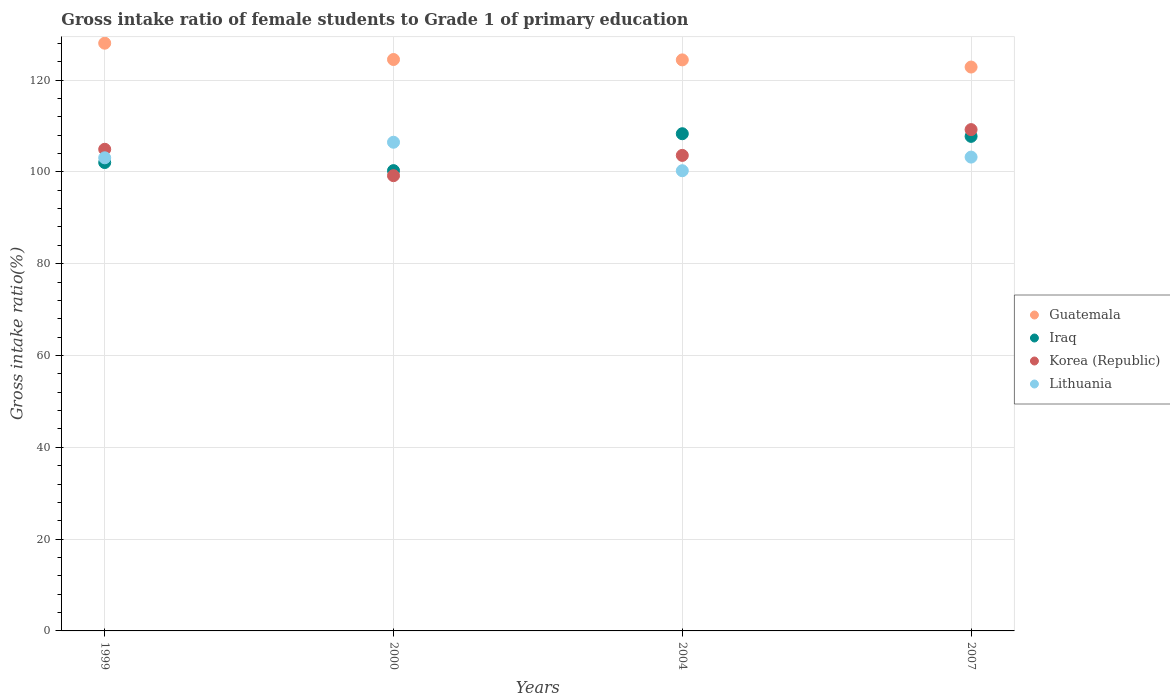How many different coloured dotlines are there?
Your response must be concise. 4. Is the number of dotlines equal to the number of legend labels?
Provide a short and direct response. Yes. What is the gross intake ratio in Iraq in 2000?
Your answer should be compact. 100.26. Across all years, what is the maximum gross intake ratio in Korea (Republic)?
Make the answer very short. 109.2. Across all years, what is the minimum gross intake ratio in Iraq?
Offer a very short reply. 100.26. In which year was the gross intake ratio in Iraq minimum?
Provide a short and direct response. 2000. What is the total gross intake ratio in Iraq in the graph?
Provide a succinct answer. 418.31. What is the difference between the gross intake ratio in Lithuania in 2004 and that in 2007?
Keep it short and to the point. -2.97. What is the difference between the gross intake ratio in Lithuania in 2004 and the gross intake ratio in Guatemala in 1999?
Provide a succinct answer. -27.78. What is the average gross intake ratio in Guatemala per year?
Provide a succinct answer. 124.93. In the year 1999, what is the difference between the gross intake ratio in Iraq and gross intake ratio in Lithuania?
Ensure brevity in your answer.  -1.03. What is the ratio of the gross intake ratio in Iraq in 2000 to that in 2007?
Your answer should be compact. 0.93. Is the gross intake ratio in Lithuania in 2000 less than that in 2004?
Provide a short and direct response. No. What is the difference between the highest and the second highest gross intake ratio in Korea (Republic)?
Offer a terse response. 4.28. What is the difference between the highest and the lowest gross intake ratio in Korea (Republic)?
Give a very brief answer. 10.03. Does the gross intake ratio in Iraq monotonically increase over the years?
Ensure brevity in your answer.  No. Is the gross intake ratio in Guatemala strictly greater than the gross intake ratio in Iraq over the years?
Your answer should be compact. Yes. How many years are there in the graph?
Give a very brief answer. 4. What is the difference between two consecutive major ticks on the Y-axis?
Provide a succinct answer. 20. Does the graph contain grids?
Give a very brief answer. Yes. What is the title of the graph?
Ensure brevity in your answer.  Gross intake ratio of female students to Grade 1 of primary education. Does "Sierra Leone" appear as one of the legend labels in the graph?
Your response must be concise. No. What is the label or title of the X-axis?
Offer a very short reply. Years. What is the label or title of the Y-axis?
Provide a short and direct response. Gross intake ratio(%). What is the Gross intake ratio(%) in Guatemala in 1999?
Ensure brevity in your answer.  128.02. What is the Gross intake ratio(%) in Iraq in 1999?
Your answer should be very brief. 102.02. What is the Gross intake ratio(%) of Korea (Republic) in 1999?
Ensure brevity in your answer.  104.91. What is the Gross intake ratio(%) in Lithuania in 1999?
Your answer should be very brief. 103.06. What is the Gross intake ratio(%) of Guatemala in 2000?
Provide a succinct answer. 124.47. What is the Gross intake ratio(%) in Iraq in 2000?
Your answer should be compact. 100.26. What is the Gross intake ratio(%) in Korea (Republic) in 2000?
Keep it short and to the point. 99.16. What is the Gross intake ratio(%) in Lithuania in 2000?
Offer a terse response. 106.45. What is the Gross intake ratio(%) of Guatemala in 2004?
Give a very brief answer. 124.38. What is the Gross intake ratio(%) of Iraq in 2004?
Make the answer very short. 108.3. What is the Gross intake ratio(%) of Korea (Republic) in 2004?
Your answer should be compact. 103.58. What is the Gross intake ratio(%) of Lithuania in 2004?
Your response must be concise. 100.24. What is the Gross intake ratio(%) of Guatemala in 2007?
Your answer should be very brief. 122.83. What is the Gross intake ratio(%) of Iraq in 2007?
Offer a terse response. 107.72. What is the Gross intake ratio(%) in Korea (Republic) in 2007?
Give a very brief answer. 109.2. What is the Gross intake ratio(%) in Lithuania in 2007?
Your answer should be compact. 103.21. Across all years, what is the maximum Gross intake ratio(%) of Guatemala?
Keep it short and to the point. 128.02. Across all years, what is the maximum Gross intake ratio(%) in Iraq?
Offer a terse response. 108.3. Across all years, what is the maximum Gross intake ratio(%) in Korea (Republic)?
Your answer should be compact. 109.2. Across all years, what is the maximum Gross intake ratio(%) in Lithuania?
Your response must be concise. 106.45. Across all years, what is the minimum Gross intake ratio(%) of Guatemala?
Provide a succinct answer. 122.83. Across all years, what is the minimum Gross intake ratio(%) of Iraq?
Provide a succinct answer. 100.26. Across all years, what is the minimum Gross intake ratio(%) in Korea (Republic)?
Offer a terse response. 99.16. Across all years, what is the minimum Gross intake ratio(%) in Lithuania?
Ensure brevity in your answer.  100.24. What is the total Gross intake ratio(%) of Guatemala in the graph?
Give a very brief answer. 499.7. What is the total Gross intake ratio(%) in Iraq in the graph?
Your answer should be compact. 418.31. What is the total Gross intake ratio(%) in Korea (Republic) in the graph?
Offer a very short reply. 416.86. What is the total Gross intake ratio(%) of Lithuania in the graph?
Offer a very short reply. 412.96. What is the difference between the Gross intake ratio(%) in Guatemala in 1999 and that in 2000?
Your answer should be compact. 3.55. What is the difference between the Gross intake ratio(%) of Iraq in 1999 and that in 2000?
Your answer should be compact. 1.76. What is the difference between the Gross intake ratio(%) in Korea (Republic) in 1999 and that in 2000?
Offer a very short reply. 5.75. What is the difference between the Gross intake ratio(%) in Lithuania in 1999 and that in 2000?
Your answer should be compact. -3.39. What is the difference between the Gross intake ratio(%) in Guatemala in 1999 and that in 2004?
Your answer should be very brief. 3.64. What is the difference between the Gross intake ratio(%) in Iraq in 1999 and that in 2004?
Offer a terse response. -6.28. What is the difference between the Gross intake ratio(%) of Korea (Republic) in 1999 and that in 2004?
Offer a terse response. 1.33. What is the difference between the Gross intake ratio(%) in Lithuania in 1999 and that in 2004?
Your answer should be very brief. 2.81. What is the difference between the Gross intake ratio(%) in Guatemala in 1999 and that in 2007?
Give a very brief answer. 5.19. What is the difference between the Gross intake ratio(%) in Iraq in 1999 and that in 2007?
Give a very brief answer. -5.7. What is the difference between the Gross intake ratio(%) of Korea (Republic) in 1999 and that in 2007?
Make the answer very short. -4.28. What is the difference between the Gross intake ratio(%) of Lithuania in 1999 and that in 2007?
Your response must be concise. -0.16. What is the difference between the Gross intake ratio(%) of Guatemala in 2000 and that in 2004?
Offer a very short reply. 0.08. What is the difference between the Gross intake ratio(%) in Iraq in 2000 and that in 2004?
Keep it short and to the point. -8.04. What is the difference between the Gross intake ratio(%) in Korea (Republic) in 2000 and that in 2004?
Your answer should be compact. -4.42. What is the difference between the Gross intake ratio(%) in Lithuania in 2000 and that in 2004?
Keep it short and to the point. 6.21. What is the difference between the Gross intake ratio(%) in Guatemala in 2000 and that in 2007?
Your response must be concise. 1.64. What is the difference between the Gross intake ratio(%) of Iraq in 2000 and that in 2007?
Offer a very short reply. -7.46. What is the difference between the Gross intake ratio(%) of Korea (Republic) in 2000 and that in 2007?
Ensure brevity in your answer.  -10.03. What is the difference between the Gross intake ratio(%) of Lithuania in 2000 and that in 2007?
Your answer should be very brief. 3.24. What is the difference between the Gross intake ratio(%) of Guatemala in 2004 and that in 2007?
Ensure brevity in your answer.  1.56. What is the difference between the Gross intake ratio(%) in Iraq in 2004 and that in 2007?
Your answer should be very brief. 0.58. What is the difference between the Gross intake ratio(%) in Korea (Republic) in 2004 and that in 2007?
Ensure brevity in your answer.  -5.62. What is the difference between the Gross intake ratio(%) of Lithuania in 2004 and that in 2007?
Offer a terse response. -2.97. What is the difference between the Gross intake ratio(%) in Guatemala in 1999 and the Gross intake ratio(%) in Iraq in 2000?
Offer a very short reply. 27.76. What is the difference between the Gross intake ratio(%) of Guatemala in 1999 and the Gross intake ratio(%) of Korea (Republic) in 2000?
Your answer should be compact. 28.86. What is the difference between the Gross intake ratio(%) of Guatemala in 1999 and the Gross intake ratio(%) of Lithuania in 2000?
Keep it short and to the point. 21.57. What is the difference between the Gross intake ratio(%) of Iraq in 1999 and the Gross intake ratio(%) of Korea (Republic) in 2000?
Provide a short and direct response. 2.86. What is the difference between the Gross intake ratio(%) of Iraq in 1999 and the Gross intake ratio(%) of Lithuania in 2000?
Your answer should be very brief. -4.42. What is the difference between the Gross intake ratio(%) of Korea (Republic) in 1999 and the Gross intake ratio(%) of Lithuania in 2000?
Make the answer very short. -1.53. What is the difference between the Gross intake ratio(%) of Guatemala in 1999 and the Gross intake ratio(%) of Iraq in 2004?
Keep it short and to the point. 19.72. What is the difference between the Gross intake ratio(%) in Guatemala in 1999 and the Gross intake ratio(%) in Korea (Republic) in 2004?
Give a very brief answer. 24.44. What is the difference between the Gross intake ratio(%) of Guatemala in 1999 and the Gross intake ratio(%) of Lithuania in 2004?
Keep it short and to the point. 27.78. What is the difference between the Gross intake ratio(%) in Iraq in 1999 and the Gross intake ratio(%) in Korea (Republic) in 2004?
Offer a terse response. -1.56. What is the difference between the Gross intake ratio(%) in Iraq in 1999 and the Gross intake ratio(%) in Lithuania in 2004?
Keep it short and to the point. 1.78. What is the difference between the Gross intake ratio(%) in Korea (Republic) in 1999 and the Gross intake ratio(%) in Lithuania in 2004?
Your answer should be compact. 4.67. What is the difference between the Gross intake ratio(%) in Guatemala in 1999 and the Gross intake ratio(%) in Iraq in 2007?
Ensure brevity in your answer.  20.3. What is the difference between the Gross intake ratio(%) in Guatemala in 1999 and the Gross intake ratio(%) in Korea (Republic) in 2007?
Keep it short and to the point. 18.82. What is the difference between the Gross intake ratio(%) of Guatemala in 1999 and the Gross intake ratio(%) of Lithuania in 2007?
Your answer should be very brief. 24.81. What is the difference between the Gross intake ratio(%) in Iraq in 1999 and the Gross intake ratio(%) in Korea (Republic) in 2007?
Offer a very short reply. -7.17. What is the difference between the Gross intake ratio(%) in Iraq in 1999 and the Gross intake ratio(%) in Lithuania in 2007?
Provide a short and direct response. -1.19. What is the difference between the Gross intake ratio(%) of Korea (Republic) in 1999 and the Gross intake ratio(%) of Lithuania in 2007?
Your answer should be compact. 1.7. What is the difference between the Gross intake ratio(%) in Guatemala in 2000 and the Gross intake ratio(%) in Iraq in 2004?
Provide a succinct answer. 16.17. What is the difference between the Gross intake ratio(%) of Guatemala in 2000 and the Gross intake ratio(%) of Korea (Republic) in 2004?
Your answer should be compact. 20.89. What is the difference between the Gross intake ratio(%) in Guatemala in 2000 and the Gross intake ratio(%) in Lithuania in 2004?
Give a very brief answer. 24.23. What is the difference between the Gross intake ratio(%) in Iraq in 2000 and the Gross intake ratio(%) in Korea (Republic) in 2004?
Keep it short and to the point. -3.32. What is the difference between the Gross intake ratio(%) of Iraq in 2000 and the Gross intake ratio(%) of Lithuania in 2004?
Provide a succinct answer. 0.02. What is the difference between the Gross intake ratio(%) of Korea (Republic) in 2000 and the Gross intake ratio(%) of Lithuania in 2004?
Provide a short and direct response. -1.08. What is the difference between the Gross intake ratio(%) of Guatemala in 2000 and the Gross intake ratio(%) of Iraq in 2007?
Ensure brevity in your answer.  16.74. What is the difference between the Gross intake ratio(%) in Guatemala in 2000 and the Gross intake ratio(%) in Korea (Republic) in 2007?
Offer a very short reply. 15.27. What is the difference between the Gross intake ratio(%) of Guatemala in 2000 and the Gross intake ratio(%) of Lithuania in 2007?
Your answer should be very brief. 21.26. What is the difference between the Gross intake ratio(%) of Iraq in 2000 and the Gross intake ratio(%) of Korea (Republic) in 2007?
Keep it short and to the point. -8.94. What is the difference between the Gross intake ratio(%) in Iraq in 2000 and the Gross intake ratio(%) in Lithuania in 2007?
Give a very brief answer. -2.95. What is the difference between the Gross intake ratio(%) in Korea (Republic) in 2000 and the Gross intake ratio(%) in Lithuania in 2007?
Offer a terse response. -4.05. What is the difference between the Gross intake ratio(%) of Guatemala in 2004 and the Gross intake ratio(%) of Iraq in 2007?
Offer a very short reply. 16.66. What is the difference between the Gross intake ratio(%) of Guatemala in 2004 and the Gross intake ratio(%) of Korea (Republic) in 2007?
Your answer should be very brief. 15.19. What is the difference between the Gross intake ratio(%) of Guatemala in 2004 and the Gross intake ratio(%) of Lithuania in 2007?
Your answer should be compact. 21.17. What is the difference between the Gross intake ratio(%) of Iraq in 2004 and the Gross intake ratio(%) of Korea (Republic) in 2007?
Your answer should be compact. -0.9. What is the difference between the Gross intake ratio(%) in Iraq in 2004 and the Gross intake ratio(%) in Lithuania in 2007?
Your answer should be very brief. 5.09. What is the difference between the Gross intake ratio(%) in Korea (Republic) in 2004 and the Gross intake ratio(%) in Lithuania in 2007?
Your response must be concise. 0.37. What is the average Gross intake ratio(%) of Guatemala per year?
Provide a short and direct response. 124.92. What is the average Gross intake ratio(%) of Iraq per year?
Your answer should be compact. 104.58. What is the average Gross intake ratio(%) of Korea (Republic) per year?
Ensure brevity in your answer.  104.21. What is the average Gross intake ratio(%) of Lithuania per year?
Offer a very short reply. 103.24. In the year 1999, what is the difference between the Gross intake ratio(%) of Guatemala and Gross intake ratio(%) of Iraq?
Offer a terse response. 26. In the year 1999, what is the difference between the Gross intake ratio(%) in Guatemala and Gross intake ratio(%) in Korea (Republic)?
Your answer should be compact. 23.11. In the year 1999, what is the difference between the Gross intake ratio(%) in Guatemala and Gross intake ratio(%) in Lithuania?
Make the answer very short. 24.96. In the year 1999, what is the difference between the Gross intake ratio(%) of Iraq and Gross intake ratio(%) of Korea (Republic)?
Your answer should be compact. -2.89. In the year 1999, what is the difference between the Gross intake ratio(%) in Iraq and Gross intake ratio(%) in Lithuania?
Offer a very short reply. -1.03. In the year 1999, what is the difference between the Gross intake ratio(%) of Korea (Republic) and Gross intake ratio(%) of Lithuania?
Ensure brevity in your answer.  1.86. In the year 2000, what is the difference between the Gross intake ratio(%) of Guatemala and Gross intake ratio(%) of Iraq?
Ensure brevity in your answer.  24.21. In the year 2000, what is the difference between the Gross intake ratio(%) in Guatemala and Gross intake ratio(%) in Korea (Republic)?
Give a very brief answer. 25.3. In the year 2000, what is the difference between the Gross intake ratio(%) in Guatemala and Gross intake ratio(%) in Lithuania?
Offer a very short reply. 18.02. In the year 2000, what is the difference between the Gross intake ratio(%) in Iraq and Gross intake ratio(%) in Korea (Republic)?
Provide a short and direct response. 1.1. In the year 2000, what is the difference between the Gross intake ratio(%) of Iraq and Gross intake ratio(%) of Lithuania?
Provide a short and direct response. -6.19. In the year 2000, what is the difference between the Gross intake ratio(%) in Korea (Republic) and Gross intake ratio(%) in Lithuania?
Make the answer very short. -7.28. In the year 2004, what is the difference between the Gross intake ratio(%) in Guatemala and Gross intake ratio(%) in Iraq?
Offer a very short reply. 16.08. In the year 2004, what is the difference between the Gross intake ratio(%) in Guatemala and Gross intake ratio(%) in Korea (Republic)?
Give a very brief answer. 20.8. In the year 2004, what is the difference between the Gross intake ratio(%) in Guatemala and Gross intake ratio(%) in Lithuania?
Ensure brevity in your answer.  24.14. In the year 2004, what is the difference between the Gross intake ratio(%) in Iraq and Gross intake ratio(%) in Korea (Republic)?
Provide a succinct answer. 4.72. In the year 2004, what is the difference between the Gross intake ratio(%) of Iraq and Gross intake ratio(%) of Lithuania?
Give a very brief answer. 8.06. In the year 2004, what is the difference between the Gross intake ratio(%) of Korea (Republic) and Gross intake ratio(%) of Lithuania?
Your answer should be compact. 3.34. In the year 2007, what is the difference between the Gross intake ratio(%) of Guatemala and Gross intake ratio(%) of Iraq?
Ensure brevity in your answer.  15.1. In the year 2007, what is the difference between the Gross intake ratio(%) of Guatemala and Gross intake ratio(%) of Korea (Republic)?
Provide a succinct answer. 13.63. In the year 2007, what is the difference between the Gross intake ratio(%) of Guatemala and Gross intake ratio(%) of Lithuania?
Your answer should be compact. 19.61. In the year 2007, what is the difference between the Gross intake ratio(%) in Iraq and Gross intake ratio(%) in Korea (Republic)?
Offer a terse response. -1.47. In the year 2007, what is the difference between the Gross intake ratio(%) of Iraq and Gross intake ratio(%) of Lithuania?
Keep it short and to the point. 4.51. In the year 2007, what is the difference between the Gross intake ratio(%) in Korea (Republic) and Gross intake ratio(%) in Lithuania?
Offer a terse response. 5.99. What is the ratio of the Gross intake ratio(%) in Guatemala in 1999 to that in 2000?
Make the answer very short. 1.03. What is the ratio of the Gross intake ratio(%) of Iraq in 1999 to that in 2000?
Your response must be concise. 1.02. What is the ratio of the Gross intake ratio(%) of Korea (Republic) in 1999 to that in 2000?
Give a very brief answer. 1.06. What is the ratio of the Gross intake ratio(%) of Lithuania in 1999 to that in 2000?
Ensure brevity in your answer.  0.97. What is the ratio of the Gross intake ratio(%) of Guatemala in 1999 to that in 2004?
Offer a very short reply. 1.03. What is the ratio of the Gross intake ratio(%) of Iraq in 1999 to that in 2004?
Provide a short and direct response. 0.94. What is the ratio of the Gross intake ratio(%) in Korea (Republic) in 1999 to that in 2004?
Ensure brevity in your answer.  1.01. What is the ratio of the Gross intake ratio(%) in Lithuania in 1999 to that in 2004?
Keep it short and to the point. 1.03. What is the ratio of the Gross intake ratio(%) in Guatemala in 1999 to that in 2007?
Your answer should be very brief. 1.04. What is the ratio of the Gross intake ratio(%) in Iraq in 1999 to that in 2007?
Ensure brevity in your answer.  0.95. What is the ratio of the Gross intake ratio(%) of Korea (Republic) in 1999 to that in 2007?
Provide a short and direct response. 0.96. What is the ratio of the Gross intake ratio(%) in Guatemala in 2000 to that in 2004?
Provide a short and direct response. 1. What is the ratio of the Gross intake ratio(%) of Iraq in 2000 to that in 2004?
Your answer should be very brief. 0.93. What is the ratio of the Gross intake ratio(%) of Korea (Republic) in 2000 to that in 2004?
Offer a very short reply. 0.96. What is the ratio of the Gross intake ratio(%) in Lithuania in 2000 to that in 2004?
Your answer should be compact. 1.06. What is the ratio of the Gross intake ratio(%) in Guatemala in 2000 to that in 2007?
Provide a succinct answer. 1.01. What is the ratio of the Gross intake ratio(%) of Iraq in 2000 to that in 2007?
Your response must be concise. 0.93. What is the ratio of the Gross intake ratio(%) of Korea (Republic) in 2000 to that in 2007?
Give a very brief answer. 0.91. What is the ratio of the Gross intake ratio(%) in Lithuania in 2000 to that in 2007?
Make the answer very short. 1.03. What is the ratio of the Gross intake ratio(%) in Guatemala in 2004 to that in 2007?
Your answer should be compact. 1.01. What is the ratio of the Gross intake ratio(%) in Iraq in 2004 to that in 2007?
Provide a succinct answer. 1.01. What is the ratio of the Gross intake ratio(%) of Korea (Republic) in 2004 to that in 2007?
Your response must be concise. 0.95. What is the ratio of the Gross intake ratio(%) of Lithuania in 2004 to that in 2007?
Offer a very short reply. 0.97. What is the difference between the highest and the second highest Gross intake ratio(%) in Guatemala?
Provide a succinct answer. 3.55. What is the difference between the highest and the second highest Gross intake ratio(%) of Iraq?
Your answer should be very brief. 0.58. What is the difference between the highest and the second highest Gross intake ratio(%) in Korea (Republic)?
Provide a succinct answer. 4.28. What is the difference between the highest and the second highest Gross intake ratio(%) in Lithuania?
Give a very brief answer. 3.24. What is the difference between the highest and the lowest Gross intake ratio(%) of Guatemala?
Make the answer very short. 5.19. What is the difference between the highest and the lowest Gross intake ratio(%) of Iraq?
Offer a terse response. 8.04. What is the difference between the highest and the lowest Gross intake ratio(%) in Korea (Republic)?
Provide a short and direct response. 10.03. What is the difference between the highest and the lowest Gross intake ratio(%) of Lithuania?
Your answer should be very brief. 6.21. 